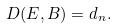Convert formula to latex. <formula><loc_0><loc_0><loc_500><loc_500>D ( E , B ) = d _ { n } .</formula> 